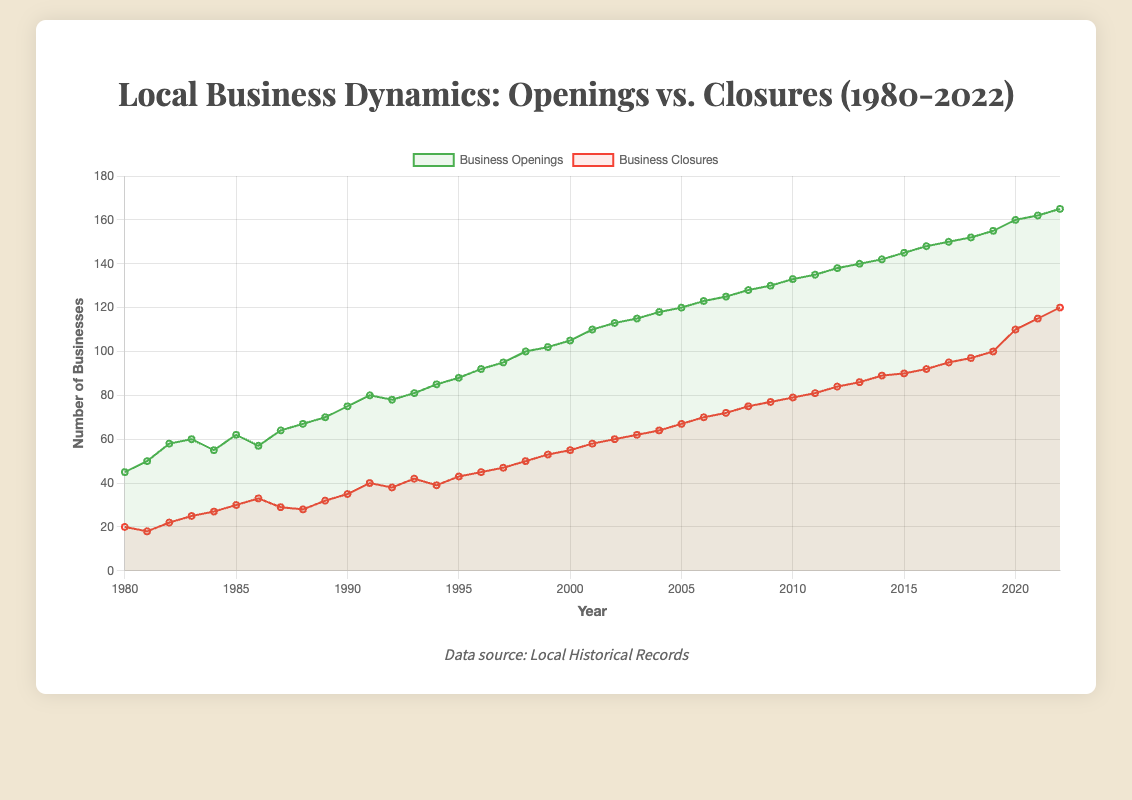How has the trend for business openings and closures changed from 1980 to 2022? To determine the trend, look at the general direction of the lines: Openings have an increasing trend, moving from 45 in 1980 to 165 in 2022. Closures also show an increasing trend, moving from 20 in 1980 to 120 in 2022.
Answer: Both openings and closures increased What year had the highest number of business openings? Identify the peak point on the 'Business Openings' line. 2022 marks the highest number of openings with 165.
Answer: 2022 Compare the number of business closures in 1990 and 2020. Which year had more closures? Look at the data points for Closures in 1990 (35) and 2020 (110); 2020 had more closures.
Answer: 2020 Calculate the average number of business openings between 1980 and 1985. Sum the business openings from 1980 to 1985 and divide by the number of years: (45 + 50 + 58 + 60 + 55 + 62) / 6 = 55.
Answer: 55 Were there any years where business openings and closures were equal? Compare the 'Business Openings' line and the 'Business Closures' line across all years. There are no points where the values are equal.
Answer: No What was the difference in the number of business closures between 2000 and 2005? Subtract the number of closures in 2000 (55) from those in 2005 (67): 67 - 55 = 12.
Answer: 12 Identify the year when the gap between business openings and closures was the narrowest. The gap is narrowest in 1987 where Openings were 64 and Closures were 29, giving a gap of 35 (lowest compared to other years).
Answer: 1987 How did business openings change from 2019 to 2020? Check the values for Openings in 2019 (155) and 2020 (160), indicating an increase of 5.
Answer: Increased by 5 What color represents the business closures line on the chart? The 'Business Closures' line is represented by a red color in the chart.
Answer: Red Calculate the difference in the number of business closures between 1985 and 2022. Subtract the closures in 1985 (30) from 2022 (120): 120 - 30 = 90.
Answer: 90 